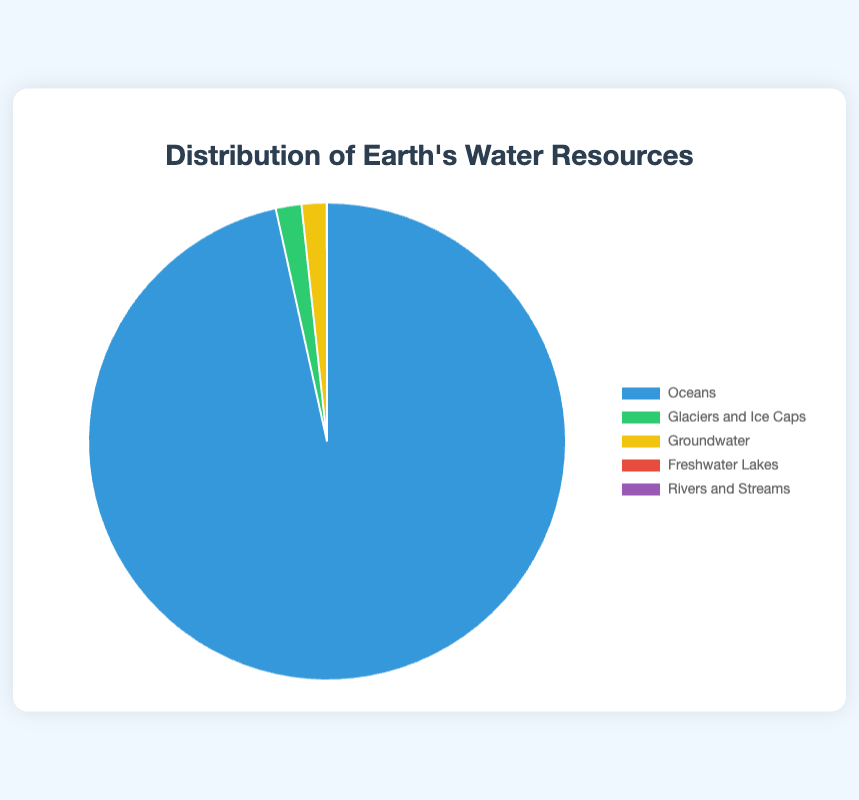Which water source has the highest percentage? The largest portion of the pie chart is labeled "Oceans," which corresponds to 96.5%. Therefore, the water source with the highest percentage is Oceans.
Answer: Oceans Which water source has the second smallest percentage? The second smallest portion on the pie chart is labeled "Freshwater Lakes," which corresponds to 0.013%.
Answer: Freshwater Lakes What is the total percentage of water resources from Glaciers and Ice Caps and Groundwater? The percentages of Glaciers and Ice Caps and Groundwater are 1.74% and 1.7%, respectively. Adding these gives 1.74 + 1.7 = 3.44%.
Answer: 3.44% Are the percentages of Groundwater and Glaciers and Ice Caps almost equal? The percentages of Groundwater and Glaciers and Ice Caps are 1.7% and 1.74%, respectively. These values are very close to each other, approximately equal.
Answer: Yes What color represents Freshwater Lakes in the pie chart? Freshwater Lakes are represented by a red color in the pie chart.
Answer: Red Combined, do Rivers and Streams and Freshwater Lakes make up more than 0.02% of the total water resources? The percentage of Rivers and Streams is 0.0002%, and that of Freshwater Lakes is 0.013%. Summing these gives 0.013 + 0.0002 = 0.0132%, which is less than 0.02%.
Answer: No How does the percentage of Oceans compare to the combined percentage of all other sources? Oceans have a percentage of 96.5%. The combined percentage of other sources is 1.74% + 1.7% + 0.013% + 0.0002% = 3.4532%. Thus, the percentage of Oceans is vastly greater than the combined percentage of other sources.
Answer: Much greater What percentage of the Earth's water resources is not in Oceans? To find the percentage not in Oceans, you subtract the percentage of Oceans from 100%: 100 - 96.5 = 3.5%.
Answer: 3.5% Which has a higher percentage: Rivers and Streams or Freshwater Lakes? Freshwater Lakes have a percentage of 0.013%, while Rivers and Streams have 0.0002%. Therefore, Freshwater Lakes have a higher percentage.
Answer: Freshwater Lakes 